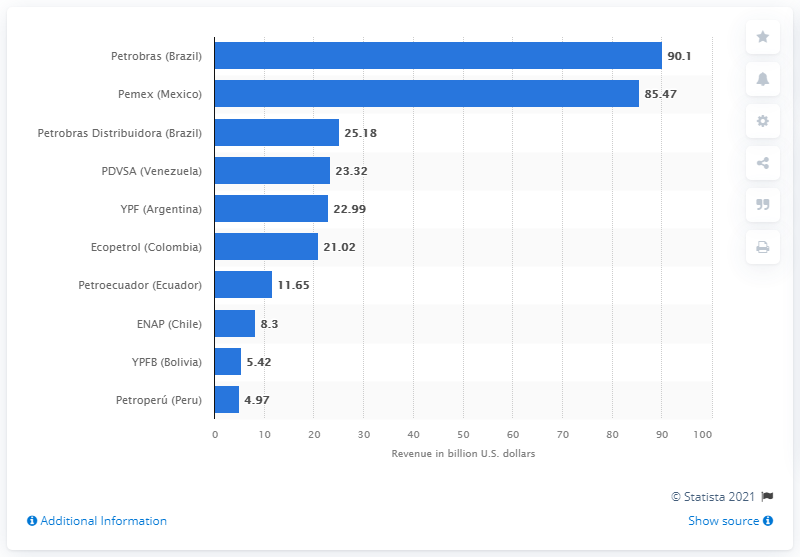Give some essential details in this illustration. Petrobras' net revenue in 2018 was 90.1 billion. 